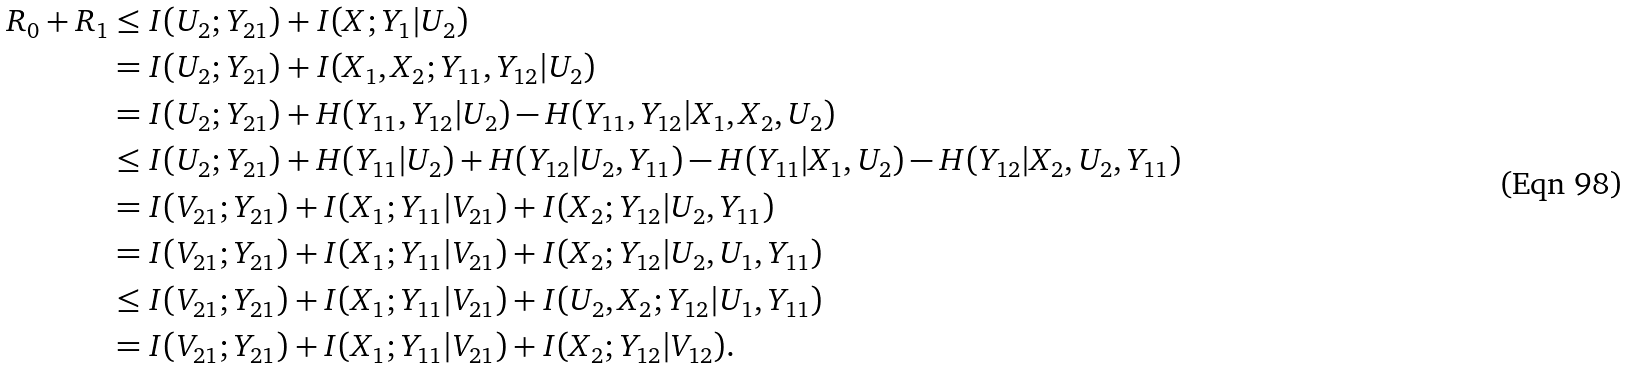Convert formula to latex. <formula><loc_0><loc_0><loc_500><loc_500>R _ { 0 } + R _ { 1 } & \leq I ( U _ { 2 } ; Y _ { 2 1 } ) + I ( X ; Y _ { 1 } | U _ { 2 } ) \\ & = I ( U _ { 2 } ; Y _ { 2 1 } ) + I ( X _ { 1 } , X _ { 2 } ; Y _ { 1 1 } , Y _ { 1 2 } | U _ { 2 } ) \\ & = I ( U _ { 2 } ; Y _ { 2 1 } ) + H ( Y _ { 1 1 } , Y _ { 1 2 } | U _ { 2 } ) - H ( Y _ { 1 1 } , Y _ { 1 2 } | X _ { 1 } , X _ { 2 } , U _ { 2 } ) \\ & \leq I ( U _ { 2 } ; Y _ { 2 1 } ) + H ( Y _ { 1 1 } | U _ { 2 } ) + H ( Y _ { 1 2 } | U _ { 2 } , Y _ { 1 1 } ) - H ( Y _ { 1 1 } | X _ { 1 } , U _ { 2 } ) - H ( Y _ { 1 2 } | X _ { 2 } , U _ { 2 } , Y _ { 1 1 } ) \\ & = I ( V _ { 2 1 } ; Y _ { 2 1 } ) + I ( X _ { 1 } ; Y _ { 1 1 } | V _ { 2 1 } ) + I ( X _ { 2 } ; Y _ { 1 2 } | U _ { 2 } , Y _ { 1 1 } ) \\ & = I ( V _ { 2 1 } ; Y _ { 2 1 } ) + I ( X _ { 1 } ; Y _ { 1 1 } | V _ { 2 1 } ) + I ( X _ { 2 } ; Y _ { 1 2 } | U _ { 2 } , U _ { 1 } , Y _ { 1 1 } ) \\ & \leq I ( V _ { 2 1 } ; Y _ { 2 1 } ) + I ( X _ { 1 } ; Y _ { 1 1 } | V _ { 2 1 } ) + I ( U _ { 2 } , X _ { 2 } ; Y _ { 1 2 } | U _ { 1 } , Y _ { 1 1 } ) \\ & = I ( V _ { 2 1 } ; Y _ { 2 1 } ) + I ( X _ { 1 } ; Y _ { 1 1 } | V _ { 2 1 } ) + I ( X _ { 2 } ; Y _ { 1 2 } | V _ { 1 2 } ) .</formula> 